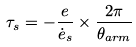Convert formula to latex. <formula><loc_0><loc_0><loc_500><loc_500>\tau _ { s } = - \frac { e } { \dot { e } _ { s } } \times \frac { 2 \pi } { \theta _ { a r m } }</formula> 